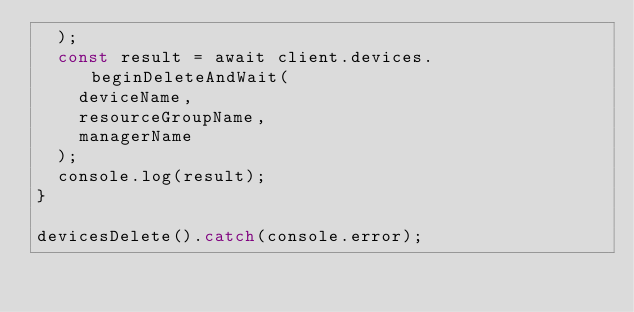Convert code to text. <code><loc_0><loc_0><loc_500><loc_500><_TypeScript_>  );
  const result = await client.devices.beginDeleteAndWait(
    deviceName,
    resourceGroupName,
    managerName
  );
  console.log(result);
}

devicesDelete().catch(console.error);
</code> 